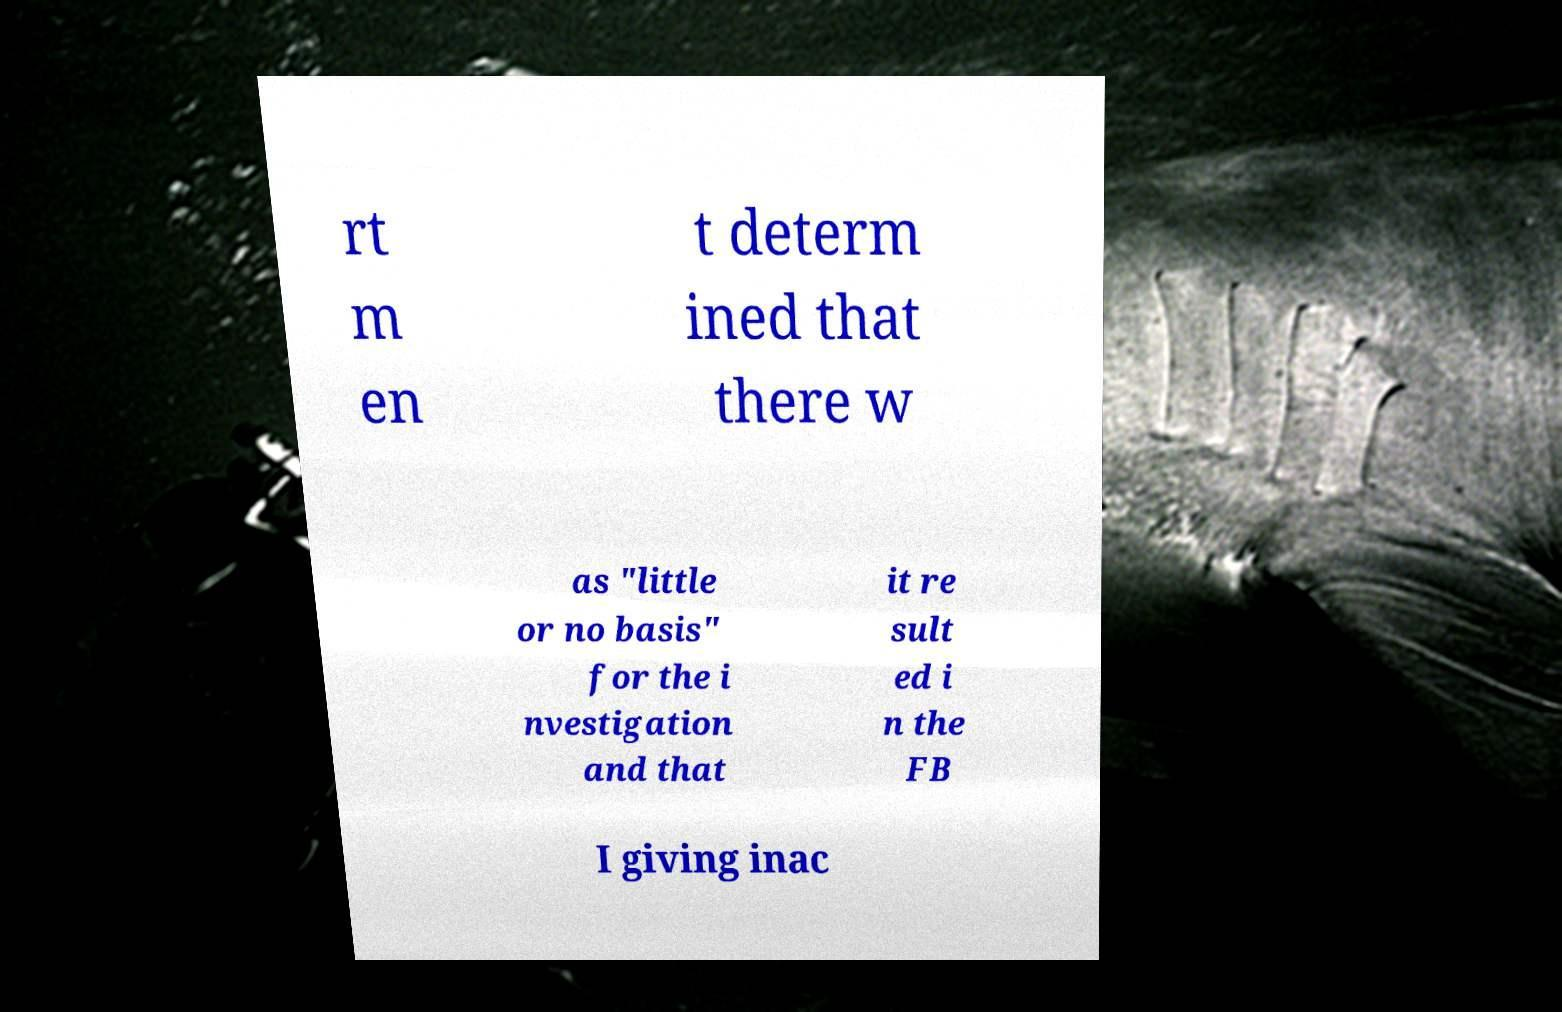Please identify and transcribe the text found in this image. rt m en t determ ined that there w as "little or no basis" for the i nvestigation and that it re sult ed i n the FB I giving inac 